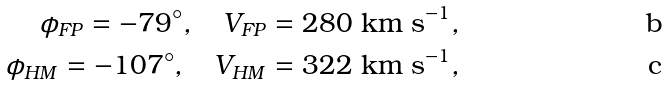Convert formula to latex. <formula><loc_0><loc_0><loc_500><loc_500>\phi _ { F P } = - 7 9 ^ { \circ } , \quad V _ { F P } = 2 8 0 \text { km s} ^ { - 1 } , \\ \phi _ { H M } = - 1 0 7 ^ { \circ } , \quad V _ { H M } = 3 2 2 \text { km s} ^ { - 1 } ,</formula> 